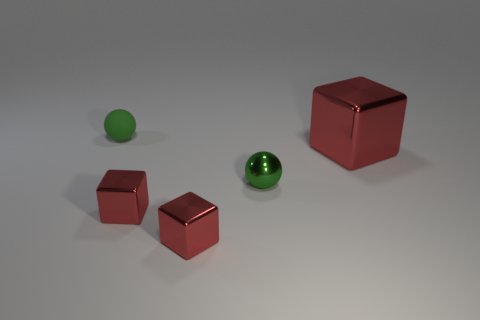Add 1 big red objects. How many objects exist? 6 Subtract all cubes. How many objects are left? 2 Subtract all green metal spheres. Subtract all metallic blocks. How many objects are left? 1 Add 1 tiny rubber spheres. How many tiny rubber spheres are left? 2 Add 2 metallic cubes. How many metallic cubes exist? 5 Subtract 0 purple cubes. How many objects are left? 5 